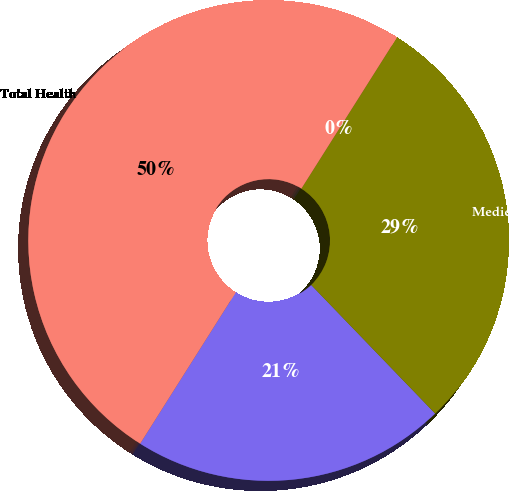Convert chart. <chart><loc_0><loc_0><loc_500><loc_500><pie_chart><fcel>Limited-benefit plans<fcel>Medicare Supplement<fcel>Medicare Part D<fcel>Total Health<nl><fcel>21.18%<fcel>28.82%<fcel>0.0%<fcel>50.0%<nl></chart> 